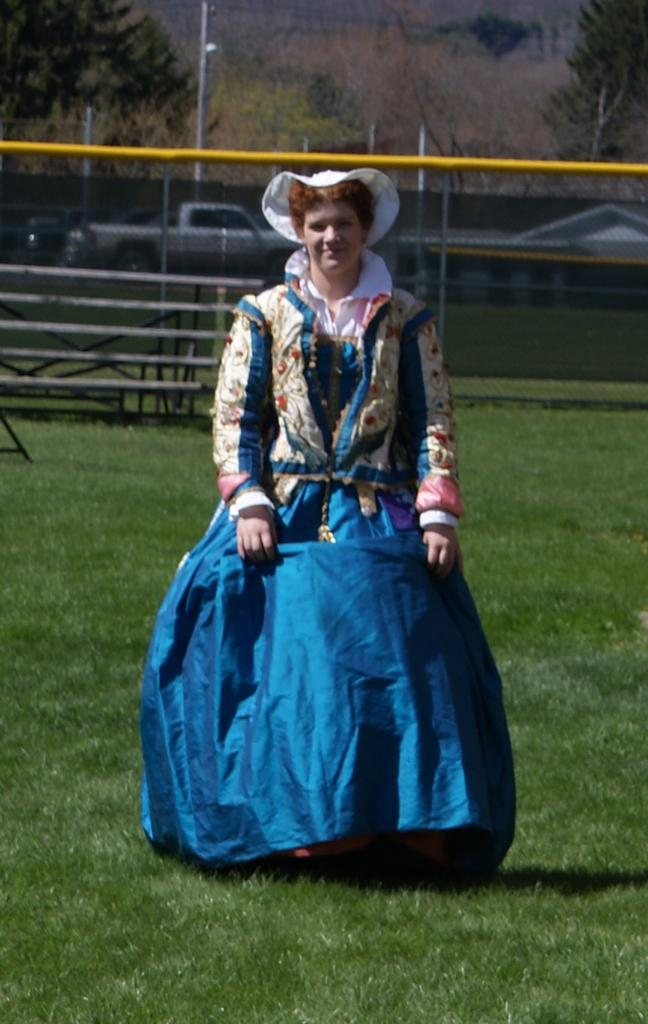Who or what is present in the image? There is a person in the image. What is the person wearing? The person is wearing a different costume. What can be seen in the background of the image? There are trees, fencing, and poles in the background of the image. What type of bear can be seen walking on the road in the image? There is no bear or road present in the image; it features a person wearing a different costume with trees, fencing, and poles in the background. 